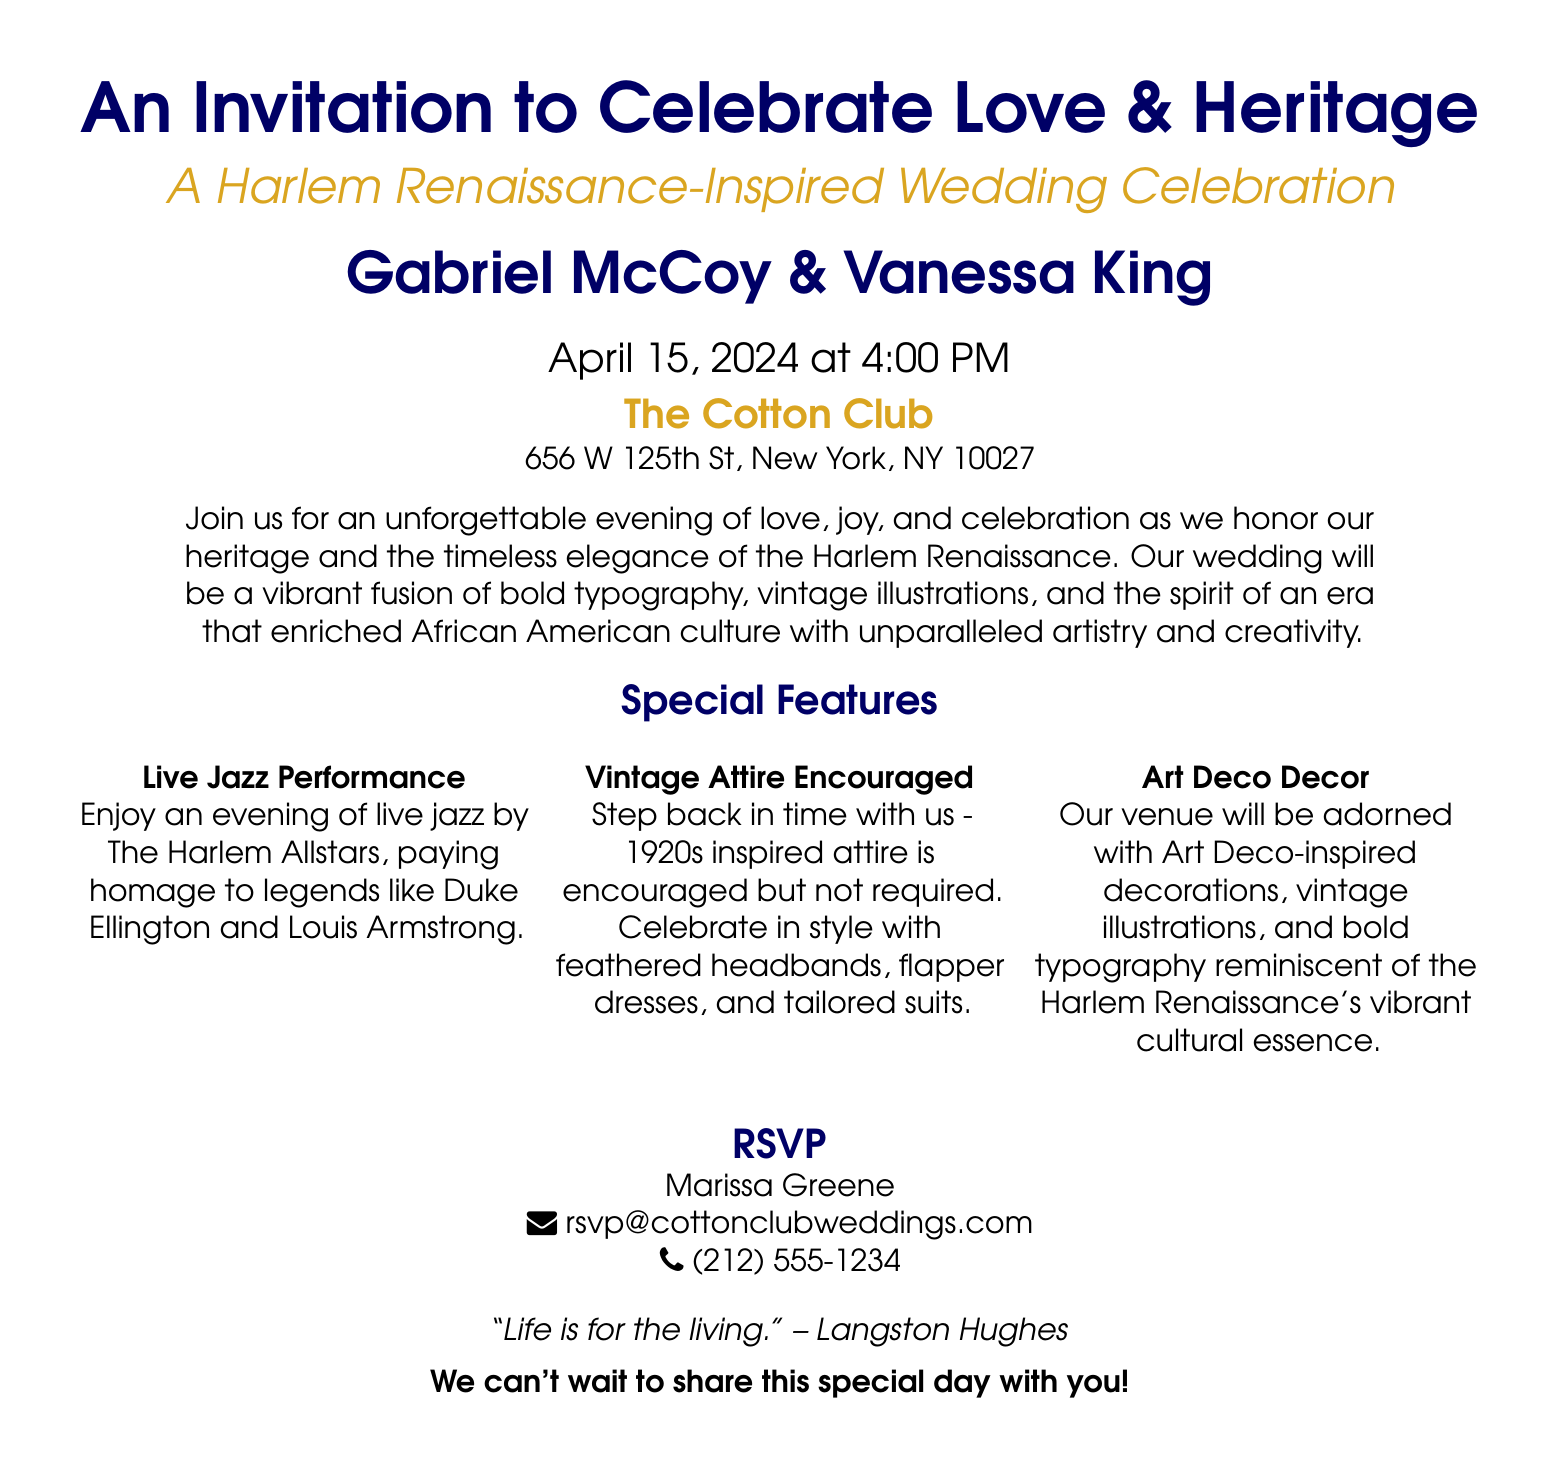What is the date of the wedding? The date is stated in the document as April 15, 2024.
Answer: April 15, 2024 Who are the couple getting married? The document mentions the names of the couple as Gabriel McCoy and Vanessa King.
Answer: Gabriel McCoy & Vanessa King What time does the wedding ceremony start? The document clearly states the ceremony will begin at 4:00 PM.
Answer: 4:00 PM What is the venue for the wedding? The invitation provides the name of the venue as The Cotton Club.
Answer: The Cotton Club What type of performance will guests enjoy? The document specifies that there will be a live jazz performance by The Harlem Allstars.
Answer: Live Jazz Performance What is encouraged for attire at the wedding? The document suggests that vintage attire inspired by the 1920s is encouraged.
Answer: Vintage Attire Encouraged What is the RSVP contact's name? The document lists Marissa Greene as the RSVP contact.
Answer: Marissa Greene Which quote is included in the invitation? The invitation features the quote “Life is for the living” by Langston Hughes.
Answer: "Life is for the living." – Langston Hughes What color is highlighted in the invitation? The invitation prominently features the color gold accent.
Answer: Gold accent 